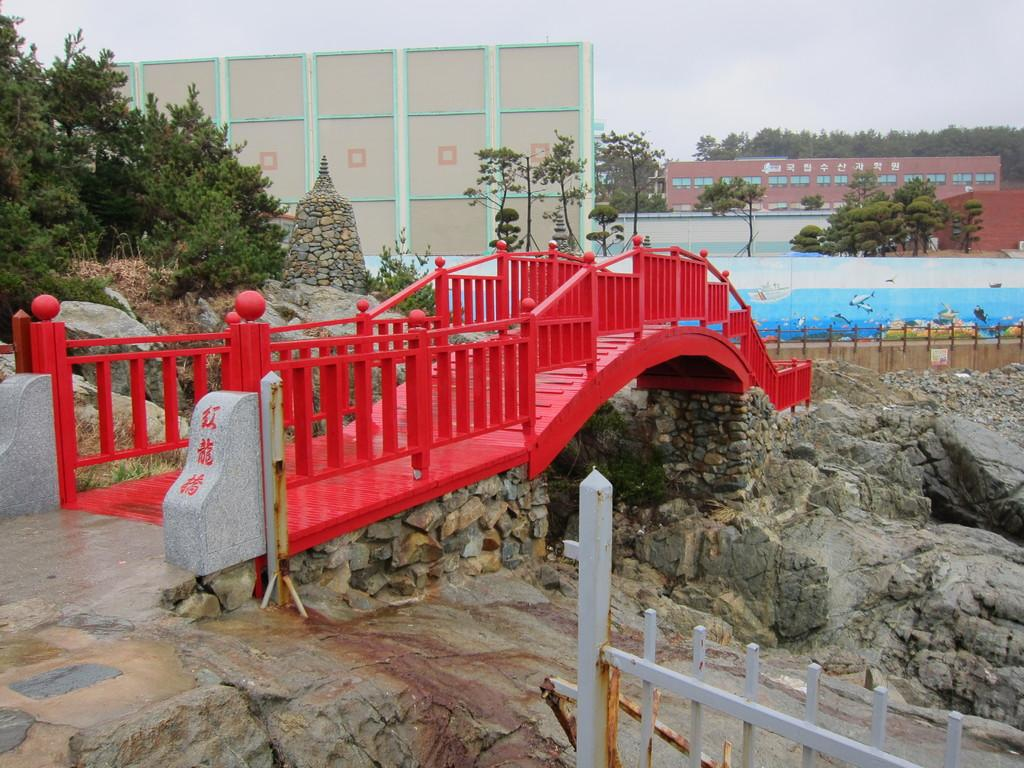What type of structure can be seen in the image? There is a fence and a bridge in the image. What other objects or features can be seen in the image? There are rocks, buildings, a wall with a painting, and trees in the image. What is visible in the background of the image? The sky is visible in the background of the image. What type of crate is being used to store the day in the image? There is no crate or day present in the image. 